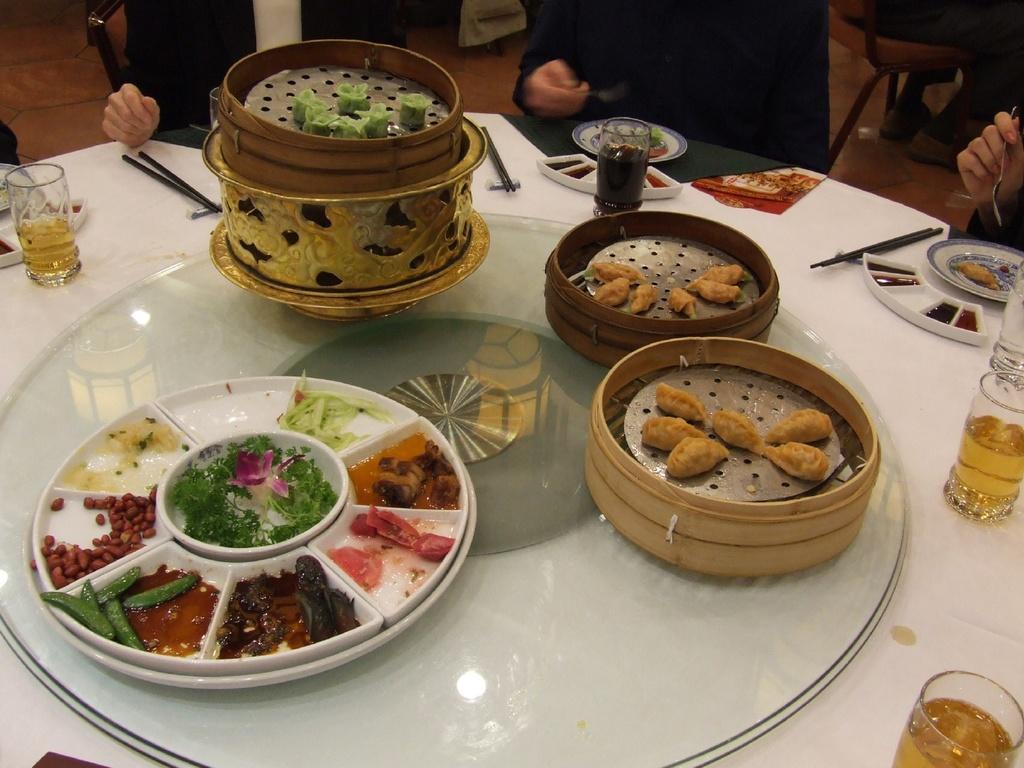Can you describe this image briefly? In this image, we can see a table, on that table there are some objects and we can see some glasses on the table, there are some people sitting on the chairs. 